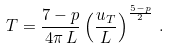Convert formula to latex. <formula><loc_0><loc_0><loc_500><loc_500>T = \frac { 7 - p } { 4 \pi \, L } \left ( \frac { u _ { T } } { L } \right ) ^ { \frac { 5 - p } { 2 } } \, .</formula> 